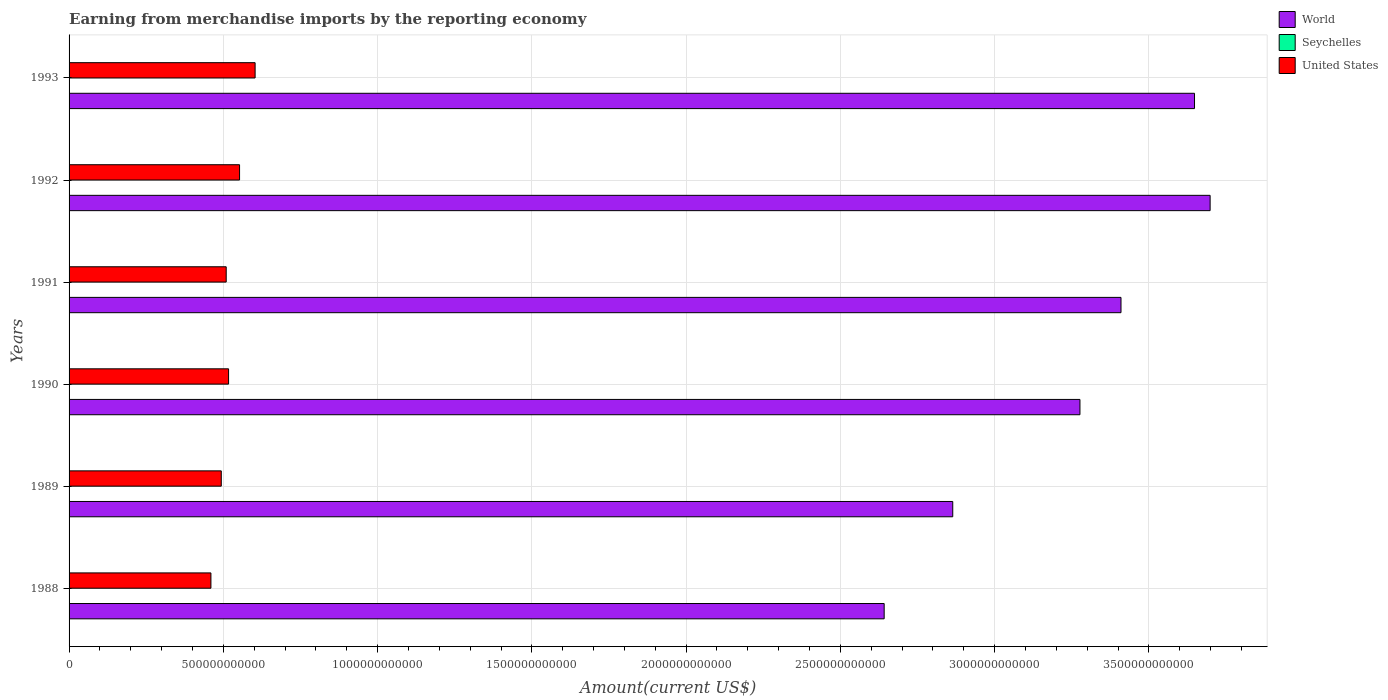How many different coloured bars are there?
Offer a terse response. 3. How many groups of bars are there?
Provide a succinct answer. 6. Are the number of bars per tick equal to the number of legend labels?
Keep it short and to the point. Yes. How many bars are there on the 4th tick from the bottom?
Keep it short and to the point. 3. What is the label of the 3rd group of bars from the top?
Keep it short and to the point. 1991. What is the amount earned from merchandise imports in United States in 1990?
Your answer should be compact. 5.17e+11. Across all years, what is the maximum amount earned from merchandise imports in United States?
Offer a very short reply. 6.03e+11. Across all years, what is the minimum amount earned from merchandise imports in Seychelles?
Your response must be concise. 1.24e+08. In which year was the amount earned from merchandise imports in World minimum?
Offer a terse response. 1988. What is the total amount earned from merchandise imports in World in the graph?
Offer a very short reply. 1.95e+13. What is the difference between the amount earned from merchandise imports in United States in 1988 and that in 1991?
Your answer should be very brief. -4.95e+1. What is the difference between the amount earned from merchandise imports in United States in 1991 and the amount earned from merchandise imports in World in 1989?
Ensure brevity in your answer.  -2.35e+12. What is the average amount earned from merchandise imports in United States per year?
Provide a short and direct response. 5.23e+11. In the year 1988, what is the difference between the amount earned from merchandise imports in Seychelles and amount earned from merchandise imports in United States?
Provide a short and direct response. -4.60e+11. In how many years, is the amount earned from merchandise imports in Seychelles greater than 3400000000000 US$?
Ensure brevity in your answer.  0. What is the ratio of the amount earned from merchandise imports in United States in 1988 to that in 1990?
Offer a very short reply. 0.89. Is the amount earned from merchandise imports in World in 1989 less than that in 1993?
Your answer should be very brief. Yes. What is the difference between the highest and the second highest amount earned from merchandise imports in Seychelles?
Provide a short and direct response. 4.61e+07. What is the difference between the highest and the lowest amount earned from merchandise imports in World?
Provide a short and direct response. 1.06e+12. In how many years, is the amount earned from merchandise imports in United States greater than the average amount earned from merchandise imports in United States taken over all years?
Give a very brief answer. 2. What does the 3rd bar from the bottom in 1989 represents?
Keep it short and to the point. United States. Is it the case that in every year, the sum of the amount earned from merchandise imports in World and amount earned from merchandise imports in United States is greater than the amount earned from merchandise imports in Seychelles?
Your answer should be compact. Yes. How many bars are there?
Provide a short and direct response. 18. What is the difference between two consecutive major ticks on the X-axis?
Your answer should be very brief. 5.00e+11. Where does the legend appear in the graph?
Your answer should be very brief. Top right. How many legend labels are there?
Your answer should be compact. 3. How are the legend labels stacked?
Offer a terse response. Vertical. What is the title of the graph?
Make the answer very short. Earning from merchandise imports by the reporting economy. Does "Central African Republic" appear as one of the legend labels in the graph?
Provide a short and direct response. No. What is the label or title of the X-axis?
Give a very brief answer. Amount(current US$). What is the Amount(current US$) in World in 1988?
Provide a short and direct response. 2.64e+12. What is the Amount(current US$) of Seychelles in 1988?
Your answer should be compact. 1.24e+08. What is the Amount(current US$) in United States in 1988?
Provide a short and direct response. 4.60e+11. What is the Amount(current US$) of World in 1989?
Keep it short and to the point. 2.86e+12. What is the Amount(current US$) in Seychelles in 1989?
Provide a succinct answer. 1.65e+08. What is the Amount(current US$) of United States in 1989?
Ensure brevity in your answer.  4.93e+11. What is the Amount(current US$) in World in 1990?
Your answer should be very brief. 3.28e+12. What is the Amount(current US$) of Seychelles in 1990?
Provide a succinct answer. 1.86e+08. What is the Amount(current US$) in United States in 1990?
Your answer should be very brief. 5.17e+11. What is the Amount(current US$) of World in 1991?
Offer a terse response. 3.41e+12. What is the Amount(current US$) of Seychelles in 1991?
Provide a short and direct response. 1.72e+08. What is the Amount(current US$) of United States in 1991?
Offer a terse response. 5.09e+11. What is the Amount(current US$) in World in 1992?
Give a very brief answer. 3.70e+12. What is the Amount(current US$) of Seychelles in 1992?
Your response must be concise. 1.92e+08. What is the Amount(current US$) in United States in 1992?
Make the answer very short. 5.53e+11. What is the Amount(current US$) in World in 1993?
Provide a succinct answer. 3.65e+12. What is the Amount(current US$) in Seychelles in 1993?
Make the answer very short. 2.38e+08. What is the Amount(current US$) of United States in 1993?
Provide a short and direct response. 6.03e+11. Across all years, what is the maximum Amount(current US$) of World?
Provide a short and direct response. 3.70e+12. Across all years, what is the maximum Amount(current US$) in Seychelles?
Provide a short and direct response. 2.38e+08. Across all years, what is the maximum Amount(current US$) of United States?
Give a very brief answer. 6.03e+11. Across all years, what is the minimum Amount(current US$) of World?
Give a very brief answer. 2.64e+12. Across all years, what is the minimum Amount(current US$) in Seychelles?
Make the answer very short. 1.24e+08. Across all years, what is the minimum Amount(current US$) of United States?
Ensure brevity in your answer.  4.60e+11. What is the total Amount(current US$) of World in the graph?
Your answer should be compact. 1.95e+13. What is the total Amount(current US$) in Seychelles in the graph?
Your response must be concise. 1.08e+09. What is the total Amount(current US$) of United States in the graph?
Give a very brief answer. 3.14e+12. What is the difference between the Amount(current US$) of World in 1988 and that in 1989?
Your answer should be very brief. -2.22e+11. What is the difference between the Amount(current US$) of Seychelles in 1988 and that in 1989?
Provide a short and direct response. -4.10e+07. What is the difference between the Amount(current US$) in United States in 1988 and that in 1989?
Provide a short and direct response. -3.36e+1. What is the difference between the Amount(current US$) of World in 1988 and that in 1990?
Provide a short and direct response. -6.35e+11. What is the difference between the Amount(current US$) of Seychelles in 1988 and that in 1990?
Keep it short and to the point. -6.28e+07. What is the difference between the Amount(current US$) of United States in 1988 and that in 1990?
Give a very brief answer. -5.72e+1. What is the difference between the Amount(current US$) in World in 1988 and that in 1991?
Provide a succinct answer. -7.68e+11. What is the difference between the Amount(current US$) of Seychelles in 1988 and that in 1991?
Provide a succinct answer. -4.87e+07. What is the difference between the Amount(current US$) of United States in 1988 and that in 1991?
Offer a very short reply. -4.95e+1. What is the difference between the Amount(current US$) of World in 1988 and that in 1992?
Offer a very short reply. -1.06e+12. What is the difference between the Amount(current US$) in Seychelles in 1988 and that in 1992?
Provide a short and direct response. -6.86e+07. What is the difference between the Amount(current US$) of United States in 1988 and that in 1992?
Make the answer very short. -9.28e+1. What is the difference between the Amount(current US$) in World in 1988 and that in 1993?
Provide a short and direct response. -1.01e+12. What is the difference between the Amount(current US$) of Seychelles in 1988 and that in 1993?
Provide a succinct answer. -1.15e+08. What is the difference between the Amount(current US$) in United States in 1988 and that in 1993?
Offer a very short reply. -1.43e+11. What is the difference between the Amount(current US$) of World in 1989 and that in 1990?
Give a very brief answer. -4.12e+11. What is the difference between the Amount(current US$) in Seychelles in 1989 and that in 1990?
Offer a terse response. -2.17e+07. What is the difference between the Amount(current US$) of United States in 1989 and that in 1990?
Make the answer very short. -2.37e+1. What is the difference between the Amount(current US$) of World in 1989 and that in 1991?
Give a very brief answer. -5.45e+11. What is the difference between the Amount(current US$) of Seychelles in 1989 and that in 1991?
Your answer should be compact. -7.62e+06. What is the difference between the Amount(current US$) of United States in 1989 and that in 1991?
Your answer should be compact. -1.60e+1. What is the difference between the Amount(current US$) of World in 1989 and that in 1992?
Your answer should be compact. -8.34e+11. What is the difference between the Amount(current US$) in Seychelles in 1989 and that in 1992?
Offer a terse response. -2.76e+07. What is the difference between the Amount(current US$) in United States in 1989 and that in 1992?
Your answer should be compact. -5.93e+1. What is the difference between the Amount(current US$) of World in 1989 and that in 1993?
Provide a short and direct response. -7.84e+11. What is the difference between the Amount(current US$) of Seychelles in 1989 and that in 1993?
Your response must be concise. -7.37e+07. What is the difference between the Amount(current US$) of United States in 1989 and that in 1993?
Provide a succinct answer. -1.10e+11. What is the difference between the Amount(current US$) in World in 1990 and that in 1991?
Keep it short and to the point. -1.33e+11. What is the difference between the Amount(current US$) of Seychelles in 1990 and that in 1991?
Your answer should be very brief. 1.41e+07. What is the difference between the Amount(current US$) in United States in 1990 and that in 1991?
Make the answer very short. 7.70e+09. What is the difference between the Amount(current US$) in World in 1990 and that in 1992?
Your answer should be very brief. -4.22e+11. What is the difference between the Amount(current US$) of Seychelles in 1990 and that in 1992?
Make the answer very short. -5.85e+06. What is the difference between the Amount(current US$) of United States in 1990 and that in 1992?
Your answer should be very brief. -3.56e+1. What is the difference between the Amount(current US$) in World in 1990 and that in 1993?
Make the answer very short. -3.71e+11. What is the difference between the Amount(current US$) of Seychelles in 1990 and that in 1993?
Your answer should be compact. -5.20e+07. What is the difference between the Amount(current US$) of United States in 1990 and that in 1993?
Give a very brief answer. -8.60e+1. What is the difference between the Amount(current US$) of World in 1991 and that in 1992?
Give a very brief answer. -2.89e+11. What is the difference between the Amount(current US$) of Seychelles in 1991 and that in 1992?
Provide a short and direct response. -1.99e+07. What is the difference between the Amount(current US$) in United States in 1991 and that in 1992?
Keep it short and to the point. -4.33e+1. What is the difference between the Amount(current US$) in World in 1991 and that in 1993?
Give a very brief answer. -2.38e+11. What is the difference between the Amount(current US$) in Seychelles in 1991 and that in 1993?
Your answer should be very brief. -6.61e+07. What is the difference between the Amount(current US$) in United States in 1991 and that in 1993?
Ensure brevity in your answer.  -9.37e+1. What is the difference between the Amount(current US$) in World in 1992 and that in 1993?
Your answer should be compact. 5.06e+1. What is the difference between the Amount(current US$) of Seychelles in 1992 and that in 1993?
Offer a terse response. -4.61e+07. What is the difference between the Amount(current US$) of United States in 1992 and that in 1993?
Offer a terse response. -5.04e+1. What is the difference between the Amount(current US$) of World in 1988 and the Amount(current US$) of Seychelles in 1989?
Provide a succinct answer. 2.64e+12. What is the difference between the Amount(current US$) in World in 1988 and the Amount(current US$) in United States in 1989?
Provide a succinct answer. 2.15e+12. What is the difference between the Amount(current US$) of Seychelles in 1988 and the Amount(current US$) of United States in 1989?
Keep it short and to the point. -4.93e+11. What is the difference between the Amount(current US$) of World in 1988 and the Amount(current US$) of Seychelles in 1990?
Keep it short and to the point. 2.64e+12. What is the difference between the Amount(current US$) of World in 1988 and the Amount(current US$) of United States in 1990?
Provide a short and direct response. 2.12e+12. What is the difference between the Amount(current US$) in Seychelles in 1988 and the Amount(current US$) in United States in 1990?
Give a very brief answer. -5.17e+11. What is the difference between the Amount(current US$) of World in 1988 and the Amount(current US$) of Seychelles in 1991?
Your answer should be very brief. 2.64e+12. What is the difference between the Amount(current US$) in World in 1988 and the Amount(current US$) in United States in 1991?
Give a very brief answer. 2.13e+12. What is the difference between the Amount(current US$) in Seychelles in 1988 and the Amount(current US$) in United States in 1991?
Give a very brief answer. -5.09e+11. What is the difference between the Amount(current US$) of World in 1988 and the Amount(current US$) of Seychelles in 1992?
Give a very brief answer. 2.64e+12. What is the difference between the Amount(current US$) of World in 1988 and the Amount(current US$) of United States in 1992?
Your response must be concise. 2.09e+12. What is the difference between the Amount(current US$) of Seychelles in 1988 and the Amount(current US$) of United States in 1992?
Provide a succinct answer. -5.52e+11. What is the difference between the Amount(current US$) in World in 1988 and the Amount(current US$) in Seychelles in 1993?
Offer a very short reply. 2.64e+12. What is the difference between the Amount(current US$) in World in 1988 and the Amount(current US$) in United States in 1993?
Give a very brief answer. 2.04e+12. What is the difference between the Amount(current US$) in Seychelles in 1988 and the Amount(current US$) in United States in 1993?
Provide a short and direct response. -6.03e+11. What is the difference between the Amount(current US$) in World in 1989 and the Amount(current US$) in Seychelles in 1990?
Offer a very short reply. 2.86e+12. What is the difference between the Amount(current US$) of World in 1989 and the Amount(current US$) of United States in 1990?
Provide a short and direct response. 2.35e+12. What is the difference between the Amount(current US$) of Seychelles in 1989 and the Amount(current US$) of United States in 1990?
Your answer should be very brief. -5.17e+11. What is the difference between the Amount(current US$) in World in 1989 and the Amount(current US$) in Seychelles in 1991?
Make the answer very short. 2.86e+12. What is the difference between the Amount(current US$) in World in 1989 and the Amount(current US$) in United States in 1991?
Provide a succinct answer. 2.35e+12. What is the difference between the Amount(current US$) of Seychelles in 1989 and the Amount(current US$) of United States in 1991?
Offer a very short reply. -5.09e+11. What is the difference between the Amount(current US$) of World in 1989 and the Amount(current US$) of Seychelles in 1992?
Make the answer very short. 2.86e+12. What is the difference between the Amount(current US$) of World in 1989 and the Amount(current US$) of United States in 1992?
Keep it short and to the point. 2.31e+12. What is the difference between the Amount(current US$) of Seychelles in 1989 and the Amount(current US$) of United States in 1992?
Your answer should be very brief. -5.52e+11. What is the difference between the Amount(current US$) in World in 1989 and the Amount(current US$) in Seychelles in 1993?
Offer a terse response. 2.86e+12. What is the difference between the Amount(current US$) in World in 1989 and the Amount(current US$) in United States in 1993?
Your answer should be compact. 2.26e+12. What is the difference between the Amount(current US$) of Seychelles in 1989 and the Amount(current US$) of United States in 1993?
Ensure brevity in your answer.  -6.03e+11. What is the difference between the Amount(current US$) of World in 1990 and the Amount(current US$) of Seychelles in 1991?
Make the answer very short. 3.28e+12. What is the difference between the Amount(current US$) of World in 1990 and the Amount(current US$) of United States in 1991?
Ensure brevity in your answer.  2.77e+12. What is the difference between the Amount(current US$) of Seychelles in 1990 and the Amount(current US$) of United States in 1991?
Provide a short and direct response. -5.09e+11. What is the difference between the Amount(current US$) in World in 1990 and the Amount(current US$) in Seychelles in 1992?
Your answer should be very brief. 3.28e+12. What is the difference between the Amount(current US$) of World in 1990 and the Amount(current US$) of United States in 1992?
Provide a short and direct response. 2.72e+12. What is the difference between the Amount(current US$) in Seychelles in 1990 and the Amount(current US$) in United States in 1992?
Offer a very short reply. -5.52e+11. What is the difference between the Amount(current US$) in World in 1990 and the Amount(current US$) in Seychelles in 1993?
Keep it short and to the point. 3.28e+12. What is the difference between the Amount(current US$) in World in 1990 and the Amount(current US$) in United States in 1993?
Make the answer very short. 2.67e+12. What is the difference between the Amount(current US$) of Seychelles in 1990 and the Amount(current US$) of United States in 1993?
Provide a short and direct response. -6.03e+11. What is the difference between the Amount(current US$) of World in 1991 and the Amount(current US$) of Seychelles in 1992?
Offer a very short reply. 3.41e+12. What is the difference between the Amount(current US$) of World in 1991 and the Amount(current US$) of United States in 1992?
Your answer should be compact. 2.86e+12. What is the difference between the Amount(current US$) of Seychelles in 1991 and the Amount(current US$) of United States in 1992?
Provide a succinct answer. -5.52e+11. What is the difference between the Amount(current US$) in World in 1991 and the Amount(current US$) in Seychelles in 1993?
Keep it short and to the point. 3.41e+12. What is the difference between the Amount(current US$) of World in 1991 and the Amount(current US$) of United States in 1993?
Your response must be concise. 2.81e+12. What is the difference between the Amount(current US$) in Seychelles in 1991 and the Amount(current US$) in United States in 1993?
Your answer should be compact. -6.03e+11. What is the difference between the Amount(current US$) of World in 1992 and the Amount(current US$) of Seychelles in 1993?
Make the answer very short. 3.70e+12. What is the difference between the Amount(current US$) of World in 1992 and the Amount(current US$) of United States in 1993?
Ensure brevity in your answer.  3.10e+12. What is the difference between the Amount(current US$) of Seychelles in 1992 and the Amount(current US$) of United States in 1993?
Make the answer very short. -6.03e+11. What is the average Amount(current US$) of World per year?
Your response must be concise. 3.26e+12. What is the average Amount(current US$) of Seychelles per year?
Make the answer very short. 1.80e+08. What is the average Amount(current US$) of United States per year?
Your answer should be very brief. 5.23e+11. In the year 1988, what is the difference between the Amount(current US$) of World and Amount(current US$) of Seychelles?
Your response must be concise. 2.64e+12. In the year 1988, what is the difference between the Amount(current US$) in World and Amount(current US$) in United States?
Keep it short and to the point. 2.18e+12. In the year 1988, what is the difference between the Amount(current US$) in Seychelles and Amount(current US$) in United States?
Provide a short and direct response. -4.60e+11. In the year 1989, what is the difference between the Amount(current US$) in World and Amount(current US$) in Seychelles?
Provide a succinct answer. 2.86e+12. In the year 1989, what is the difference between the Amount(current US$) of World and Amount(current US$) of United States?
Provide a succinct answer. 2.37e+12. In the year 1989, what is the difference between the Amount(current US$) of Seychelles and Amount(current US$) of United States?
Provide a succinct answer. -4.93e+11. In the year 1990, what is the difference between the Amount(current US$) of World and Amount(current US$) of Seychelles?
Give a very brief answer. 3.28e+12. In the year 1990, what is the difference between the Amount(current US$) of World and Amount(current US$) of United States?
Your response must be concise. 2.76e+12. In the year 1990, what is the difference between the Amount(current US$) in Seychelles and Amount(current US$) in United States?
Your response must be concise. -5.17e+11. In the year 1991, what is the difference between the Amount(current US$) in World and Amount(current US$) in Seychelles?
Your answer should be compact. 3.41e+12. In the year 1991, what is the difference between the Amount(current US$) of World and Amount(current US$) of United States?
Provide a short and direct response. 2.90e+12. In the year 1991, what is the difference between the Amount(current US$) of Seychelles and Amount(current US$) of United States?
Ensure brevity in your answer.  -5.09e+11. In the year 1992, what is the difference between the Amount(current US$) in World and Amount(current US$) in Seychelles?
Offer a very short reply. 3.70e+12. In the year 1992, what is the difference between the Amount(current US$) of World and Amount(current US$) of United States?
Make the answer very short. 3.15e+12. In the year 1992, what is the difference between the Amount(current US$) in Seychelles and Amount(current US$) in United States?
Offer a terse response. -5.52e+11. In the year 1993, what is the difference between the Amount(current US$) of World and Amount(current US$) of Seychelles?
Ensure brevity in your answer.  3.65e+12. In the year 1993, what is the difference between the Amount(current US$) in World and Amount(current US$) in United States?
Offer a terse response. 3.04e+12. In the year 1993, what is the difference between the Amount(current US$) in Seychelles and Amount(current US$) in United States?
Provide a succinct answer. -6.03e+11. What is the ratio of the Amount(current US$) of World in 1988 to that in 1989?
Your answer should be compact. 0.92. What is the ratio of the Amount(current US$) of Seychelles in 1988 to that in 1989?
Your answer should be compact. 0.75. What is the ratio of the Amount(current US$) of United States in 1988 to that in 1989?
Your answer should be very brief. 0.93. What is the ratio of the Amount(current US$) in World in 1988 to that in 1990?
Make the answer very short. 0.81. What is the ratio of the Amount(current US$) in Seychelles in 1988 to that in 1990?
Your answer should be compact. 0.66. What is the ratio of the Amount(current US$) in United States in 1988 to that in 1990?
Offer a very short reply. 0.89. What is the ratio of the Amount(current US$) in World in 1988 to that in 1991?
Ensure brevity in your answer.  0.77. What is the ratio of the Amount(current US$) in Seychelles in 1988 to that in 1991?
Offer a very short reply. 0.72. What is the ratio of the Amount(current US$) in United States in 1988 to that in 1991?
Give a very brief answer. 0.9. What is the ratio of the Amount(current US$) of Seychelles in 1988 to that in 1992?
Make the answer very short. 0.64. What is the ratio of the Amount(current US$) of United States in 1988 to that in 1992?
Your answer should be very brief. 0.83. What is the ratio of the Amount(current US$) in World in 1988 to that in 1993?
Make the answer very short. 0.72. What is the ratio of the Amount(current US$) in Seychelles in 1988 to that in 1993?
Ensure brevity in your answer.  0.52. What is the ratio of the Amount(current US$) in United States in 1988 to that in 1993?
Provide a short and direct response. 0.76. What is the ratio of the Amount(current US$) of World in 1989 to that in 1990?
Your answer should be very brief. 0.87. What is the ratio of the Amount(current US$) in Seychelles in 1989 to that in 1990?
Provide a short and direct response. 0.88. What is the ratio of the Amount(current US$) of United States in 1989 to that in 1990?
Offer a terse response. 0.95. What is the ratio of the Amount(current US$) of World in 1989 to that in 1991?
Make the answer very short. 0.84. What is the ratio of the Amount(current US$) in Seychelles in 1989 to that in 1991?
Keep it short and to the point. 0.96. What is the ratio of the Amount(current US$) of United States in 1989 to that in 1991?
Ensure brevity in your answer.  0.97. What is the ratio of the Amount(current US$) in World in 1989 to that in 1992?
Provide a short and direct response. 0.77. What is the ratio of the Amount(current US$) of Seychelles in 1989 to that in 1992?
Give a very brief answer. 0.86. What is the ratio of the Amount(current US$) in United States in 1989 to that in 1992?
Your answer should be compact. 0.89. What is the ratio of the Amount(current US$) in World in 1989 to that in 1993?
Offer a very short reply. 0.79. What is the ratio of the Amount(current US$) of Seychelles in 1989 to that in 1993?
Your response must be concise. 0.69. What is the ratio of the Amount(current US$) of United States in 1989 to that in 1993?
Ensure brevity in your answer.  0.82. What is the ratio of the Amount(current US$) in Seychelles in 1990 to that in 1991?
Provide a succinct answer. 1.08. What is the ratio of the Amount(current US$) in United States in 1990 to that in 1991?
Provide a succinct answer. 1.02. What is the ratio of the Amount(current US$) in World in 1990 to that in 1992?
Offer a very short reply. 0.89. What is the ratio of the Amount(current US$) of Seychelles in 1990 to that in 1992?
Your answer should be compact. 0.97. What is the ratio of the Amount(current US$) of United States in 1990 to that in 1992?
Ensure brevity in your answer.  0.94. What is the ratio of the Amount(current US$) of World in 1990 to that in 1993?
Keep it short and to the point. 0.9. What is the ratio of the Amount(current US$) of Seychelles in 1990 to that in 1993?
Keep it short and to the point. 0.78. What is the ratio of the Amount(current US$) in United States in 1990 to that in 1993?
Your response must be concise. 0.86. What is the ratio of the Amount(current US$) of World in 1991 to that in 1992?
Offer a very short reply. 0.92. What is the ratio of the Amount(current US$) of Seychelles in 1991 to that in 1992?
Provide a succinct answer. 0.9. What is the ratio of the Amount(current US$) in United States in 1991 to that in 1992?
Your answer should be very brief. 0.92. What is the ratio of the Amount(current US$) in World in 1991 to that in 1993?
Your answer should be very brief. 0.93. What is the ratio of the Amount(current US$) in Seychelles in 1991 to that in 1993?
Offer a terse response. 0.72. What is the ratio of the Amount(current US$) in United States in 1991 to that in 1993?
Your answer should be very brief. 0.84. What is the ratio of the Amount(current US$) in World in 1992 to that in 1993?
Keep it short and to the point. 1.01. What is the ratio of the Amount(current US$) in Seychelles in 1992 to that in 1993?
Your answer should be very brief. 0.81. What is the ratio of the Amount(current US$) in United States in 1992 to that in 1993?
Your answer should be compact. 0.92. What is the difference between the highest and the second highest Amount(current US$) in World?
Keep it short and to the point. 5.06e+1. What is the difference between the highest and the second highest Amount(current US$) in Seychelles?
Your answer should be compact. 4.61e+07. What is the difference between the highest and the second highest Amount(current US$) of United States?
Your answer should be compact. 5.04e+1. What is the difference between the highest and the lowest Amount(current US$) in World?
Provide a short and direct response. 1.06e+12. What is the difference between the highest and the lowest Amount(current US$) of Seychelles?
Ensure brevity in your answer.  1.15e+08. What is the difference between the highest and the lowest Amount(current US$) of United States?
Ensure brevity in your answer.  1.43e+11. 